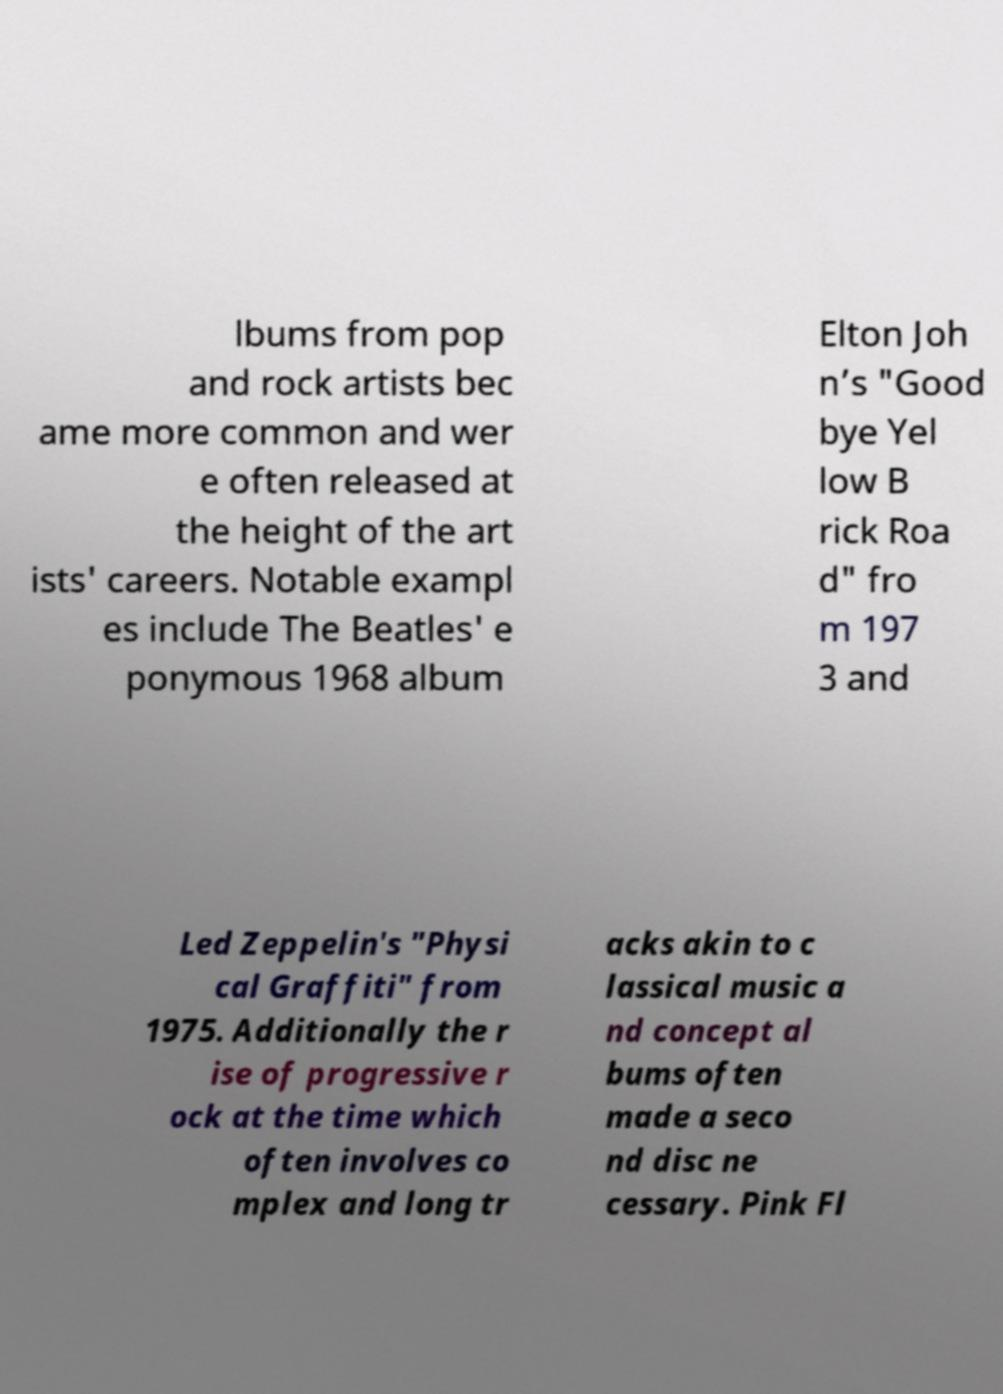For documentation purposes, I need the text within this image transcribed. Could you provide that? lbums from pop and rock artists bec ame more common and wer e often released at the height of the art ists' careers. Notable exampl es include The Beatles' e ponymous 1968 album Elton Joh n’s "Good bye Yel low B rick Roa d" fro m 197 3 and Led Zeppelin's "Physi cal Graffiti" from 1975. Additionally the r ise of progressive r ock at the time which often involves co mplex and long tr acks akin to c lassical music a nd concept al bums often made a seco nd disc ne cessary. Pink Fl 